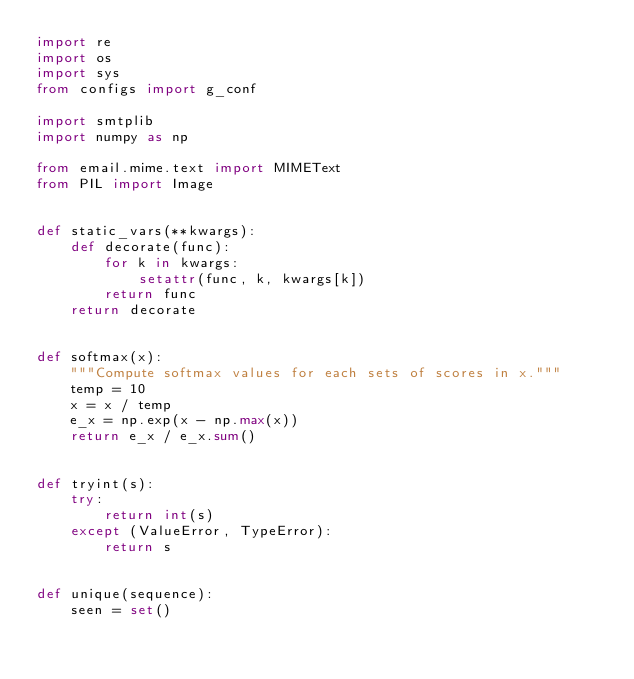<code> <loc_0><loc_0><loc_500><loc_500><_Python_>import re
import os
import sys
from configs import g_conf

import smtplib
import numpy as np

from email.mime.text import MIMEText
from PIL import Image


def static_vars(**kwargs):
    def decorate(func):
        for k in kwargs:
            setattr(func, k, kwargs[k])
        return func
    return decorate


def softmax(x):
    """Compute softmax values for each sets of scores in x."""
    temp = 10
    x = x / temp
    e_x = np.exp(x - np.max(x))
    return e_x / e_x.sum()


def tryint(s):
    try:
        return int(s)
    except (ValueError, TypeError):
        return s


def unique(sequence):
    seen = set()</code> 